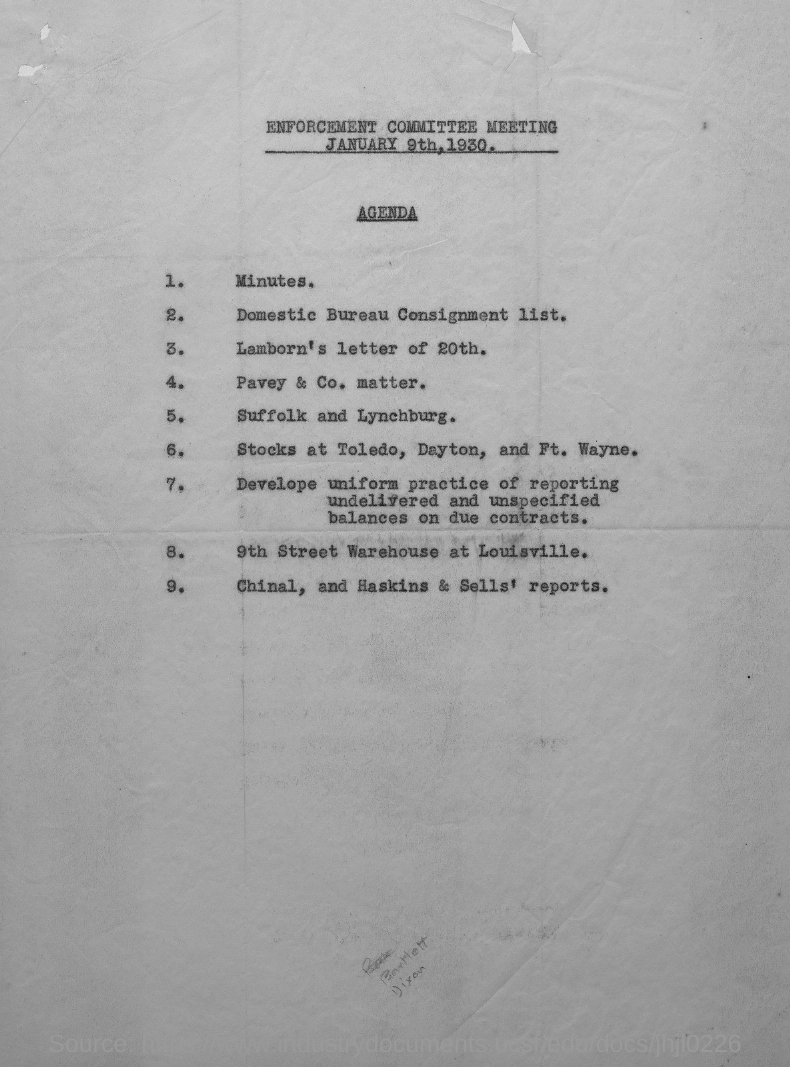When is the enforcement committee meeting held?
Keep it short and to the point. JANUARY 9TH, 1930. Which meeting agenda is given here?
Offer a terse response. ENFORCEMENT COMMITTEE MEETING JANUARY 9th, 1930. 